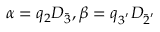Convert formula to latex. <formula><loc_0><loc_0><loc_500><loc_500>\alpha = q _ { 2 } D _ { \bar { 3 } } , \beta = q _ { 3 ^ { ^ { \prime } } } D _ { \bar { 2 } ^ { ^ { \prime } } }</formula> 